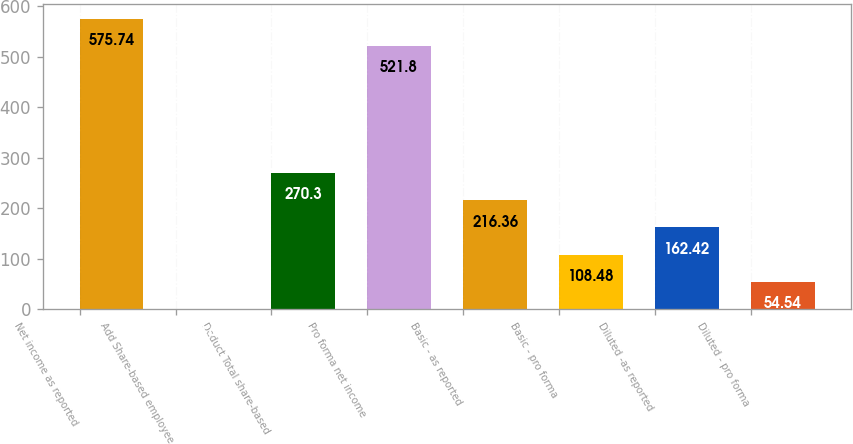Convert chart. <chart><loc_0><loc_0><loc_500><loc_500><bar_chart><fcel>Net income as reported<fcel>Add Share-based employee<fcel>Deduct Total share-based<fcel>Pro forma net income<fcel>Basic - as reported<fcel>Basic - pro forma<fcel>Diluted -as reported<fcel>Diluted - pro forma<nl><fcel>575.74<fcel>0.6<fcel>270.3<fcel>521.8<fcel>216.36<fcel>108.48<fcel>162.42<fcel>54.54<nl></chart> 